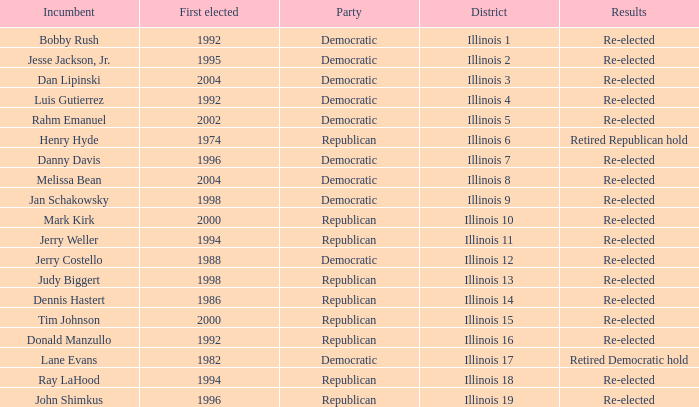I'm looking to parse the entire table for insights. Could you assist me with that? {'header': ['Incumbent', 'First elected', 'Party', 'District', 'Results'], 'rows': [['Bobby Rush', '1992', 'Democratic', 'Illinois 1', 'Re-elected'], ['Jesse Jackson, Jr.', '1995', 'Democratic', 'Illinois 2', 'Re-elected'], ['Dan Lipinski', '2004', 'Democratic', 'Illinois 3', 'Re-elected'], ['Luis Gutierrez', '1992', 'Democratic', 'Illinois 4', 'Re-elected'], ['Rahm Emanuel', '2002', 'Democratic', 'Illinois 5', 'Re-elected'], ['Henry Hyde', '1974', 'Republican', 'Illinois 6', 'Retired Republican hold'], ['Danny Davis', '1996', 'Democratic', 'Illinois 7', 'Re-elected'], ['Melissa Bean', '2004', 'Democratic', 'Illinois 8', 'Re-elected'], ['Jan Schakowsky', '1998', 'Democratic', 'Illinois 9', 'Re-elected'], ['Mark Kirk', '2000', 'Republican', 'Illinois 10', 'Re-elected'], ['Jerry Weller', '1994', 'Republican', 'Illinois 11', 'Re-elected'], ['Jerry Costello', '1988', 'Democratic', 'Illinois 12', 'Re-elected'], ['Judy Biggert', '1998', 'Republican', 'Illinois 13', 'Re-elected'], ['Dennis Hastert', '1986', 'Republican', 'Illinois 14', 'Re-elected'], ['Tim Johnson', '2000', 'Republican', 'Illinois 15', 'Re-elected'], ['Donald Manzullo', '1992', 'Republican', 'Illinois 16', 'Re-elected'], ['Lane Evans', '1982', 'Democratic', 'Illinois 17', 'Retired Democratic hold'], ['Ray LaHood', '1994', 'Republican', 'Illinois 18', 'Re-elected'], ['John Shimkus', '1996', 'Republican', 'Illinois 19', 'Re-elected']]} What is the First Elected date of the Republican with Results of retired republican hold? 1974.0. 